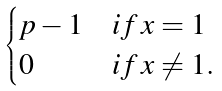Convert formula to latex. <formula><loc_0><loc_0><loc_500><loc_500>\begin{cases} p - 1 & i f \, x = 1 \\ 0 & i f \, x \neq 1 . \end{cases}</formula> 